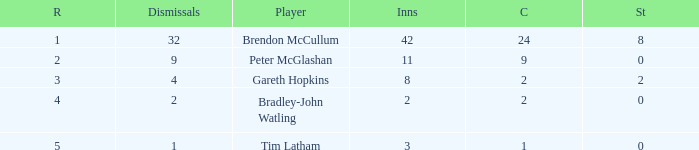List the ranks of all dismissals with a value of 4 3.0. 